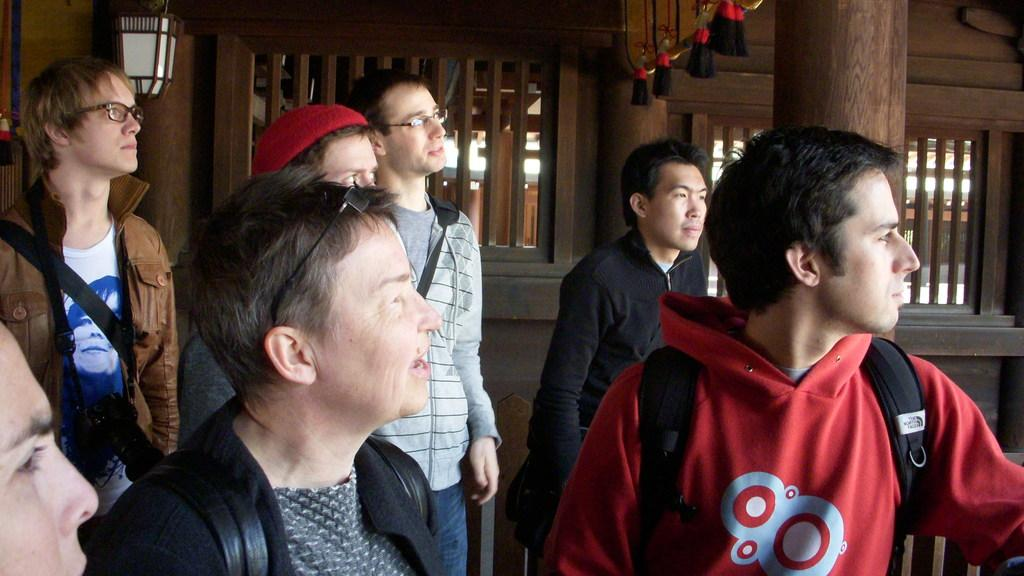What is the main subject of the image? The main subject of the image is a group of people standing. Can you describe the background of the image? In the background of the image, there are wooden windows visible. What type of feast is being prepared by the fireman in the office setting? There is no feast, fireman, or office setting present in the image. 